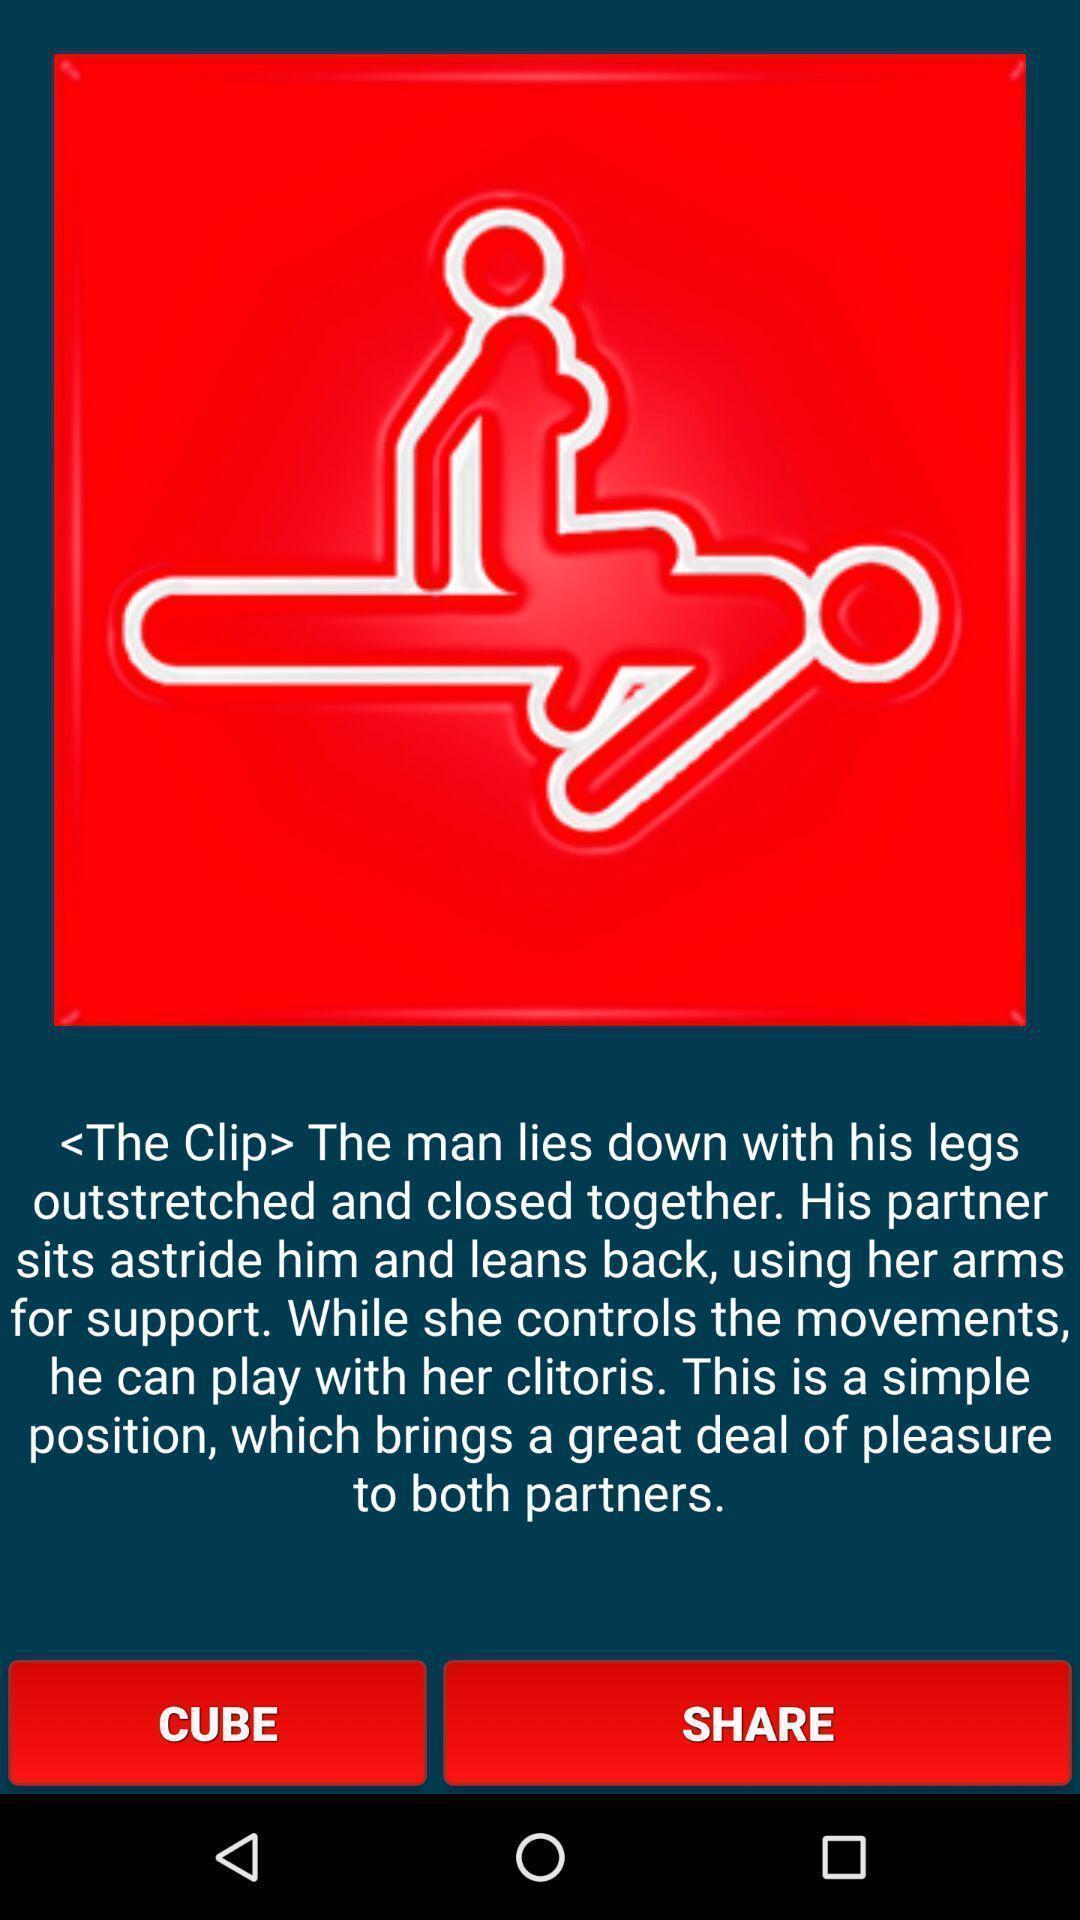Tell me about the visual elements in this screen capture. Screen displaying page. 